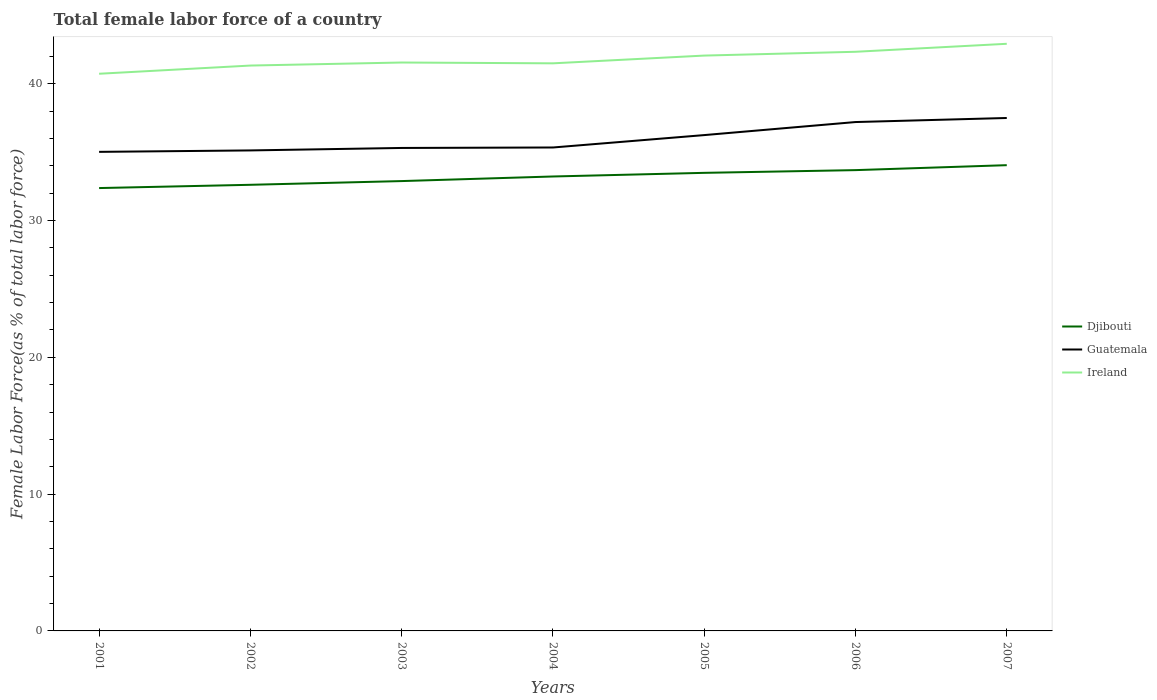How many different coloured lines are there?
Give a very brief answer. 3. Is the number of lines equal to the number of legend labels?
Offer a very short reply. Yes. Across all years, what is the maximum percentage of female labor force in Guatemala?
Provide a short and direct response. 35.02. In which year was the percentage of female labor force in Ireland maximum?
Your answer should be compact. 2001. What is the total percentage of female labor force in Djibouti in the graph?
Offer a terse response. -1.11. What is the difference between the highest and the second highest percentage of female labor force in Ireland?
Make the answer very short. 2.19. Is the percentage of female labor force in Djibouti strictly greater than the percentage of female labor force in Guatemala over the years?
Offer a terse response. Yes. How many lines are there?
Ensure brevity in your answer.  3. Are the values on the major ticks of Y-axis written in scientific E-notation?
Make the answer very short. No. Does the graph contain grids?
Offer a terse response. No. How many legend labels are there?
Your response must be concise. 3. How are the legend labels stacked?
Make the answer very short. Vertical. What is the title of the graph?
Your answer should be very brief. Total female labor force of a country. What is the label or title of the X-axis?
Your answer should be compact. Years. What is the label or title of the Y-axis?
Your response must be concise. Female Labor Force(as % of total labor force). What is the Female Labor Force(as % of total labor force) of Djibouti in 2001?
Your answer should be compact. 32.37. What is the Female Labor Force(as % of total labor force) of Guatemala in 2001?
Offer a very short reply. 35.02. What is the Female Labor Force(as % of total labor force) of Ireland in 2001?
Ensure brevity in your answer.  40.73. What is the Female Labor Force(as % of total labor force) in Djibouti in 2002?
Your answer should be compact. 32.61. What is the Female Labor Force(as % of total labor force) of Guatemala in 2002?
Ensure brevity in your answer.  35.13. What is the Female Labor Force(as % of total labor force) in Ireland in 2002?
Your answer should be very brief. 41.33. What is the Female Labor Force(as % of total labor force) in Djibouti in 2003?
Provide a short and direct response. 32.89. What is the Female Labor Force(as % of total labor force) in Guatemala in 2003?
Keep it short and to the point. 35.31. What is the Female Labor Force(as % of total labor force) in Ireland in 2003?
Ensure brevity in your answer.  41.55. What is the Female Labor Force(as % of total labor force) of Djibouti in 2004?
Make the answer very short. 33.22. What is the Female Labor Force(as % of total labor force) of Guatemala in 2004?
Ensure brevity in your answer.  35.34. What is the Female Labor Force(as % of total labor force) in Ireland in 2004?
Provide a short and direct response. 41.49. What is the Female Labor Force(as % of total labor force) of Djibouti in 2005?
Provide a short and direct response. 33.49. What is the Female Labor Force(as % of total labor force) of Guatemala in 2005?
Offer a very short reply. 36.25. What is the Female Labor Force(as % of total labor force) in Ireland in 2005?
Ensure brevity in your answer.  42.06. What is the Female Labor Force(as % of total labor force) of Djibouti in 2006?
Provide a succinct answer. 33.69. What is the Female Labor Force(as % of total labor force) of Guatemala in 2006?
Your answer should be compact. 37.2. What is the Female Labor Force(as % of total labor force) of Ireland in 2006?
Make the answer very short. 42.34. What is the Female Labor Force(as % of total labor force) in Djibouti in 2007?
Give a very brief answer. 34.05. What is the Female Labor Force(as % of total labor force) of Guatemala in 2007?
Keep it short and to the point. 37.5. What is the Female Labor Force(as % of total labor force) of Ireland in 2007?
Keep it short and to the point. 42.92. Across all years, what is the maximum Female Labor Force(as % of total labor force) of Djibouti?
Give a very brief answer. 34.05. Across all years, what is the maximum Female Labor Force(as % of total labor force) of Guatemala?
Your answer should be very brief. 37.5. Across all years, what is the maximum Female Labor Force(as % of total labor force) in Ireland?
Your response must be concise. 42.92. Across all years, what is the minimum Female Labor Force(as % of total labor force) of Djibouti?
Ensure brevity in your answer.  32.37. Across all years, what is the minimum Female Labor Force(as % of total labor force) of Guatemala?
Your answer should be very brief. 35.02. Across all years, what is the minimum Female Labor Force(as % of total labor force) of Ireland?
Provide a short and direct response. 40.73. What is the total Female Labor Force(as % of total labor force) of Djibouti in the graph?
Your answer should be very brief. 232.32. What is the total Female Labor Force(as % of total labor force) of Guatemala in the graph?
Provide a succinct answer. 251.74. What is the total Female Labor Force(as % of total labor force) in Ireland in the graph?
Offer a very short reply. 292.43. What is the difference between the Female Labor Force(as % of total labor force) in Djibouti in 2001 and that in 2002?
Give a very brief answer. -0.24. What is the difference between the Female Labor Force(as % of total labor force) in Guatemala in 2001 and that in 2002?
Provide a succinct answer. -0.1. What is the difference between the Female Labor Force(as % of total labor force) in Ireland in 2001 and that in 2002?
Provide a succinct answer. -0.6. What is the difference between the Female Labor Force(as % of total labor force) of Djibouti in 2001 and that in 2003?
Ensure brevity in your answer.  -0.51. What is the difference between the Female Labor Force(as % of total labor force) of Guatemala in 2001 and that in 2003?
Give a very brief answer. -0.29. What is the difference between the Female Labor Force(as % of total labor force) of Ireland in 2001 and that in 2003?
Keep it short and to the point. -0.82. What is the difference between the Female Labor Force(as % of total labor force) in Djibouti in 2001 and that in 2004?
Your answer should be very brief. -0.85. What is the difference between the Female Labor Force(as % of total labor force) in Guatemala in 2001 and that in 2004?
Make the answer very short. -0.32. What is the difference between the Female Labor Force(as % of total labor force) in Ireland in 2001 and that in 2004?
Ensure brevity in your answer.  -0.76. What is the difference between the Female Labor Force(as % of total labor force) in Djibouti in 2001 and that in 2005?
Your answer should be compact. -1.11. What is the difference between the Female Labor Force(as % of total labor force) in Guatemala in 2001 and that in 2005?
Give a very brief answer. -1.23. What is the difference between the Female Labor Force(as % of total labor force) of Ireland in 2001 and that in 2005?
Make the answer very short. -1.33. What is the difference between the Female Labor Force(as % of total labor force) in Djibouti in 2001 and that in 2006?
Your response must be concise. -1.31. What is the difference between the Female Labor Force(as % of total labor force) in Guatemala in 2001 and that in 2006?
Offer a terse response. -2.18. What is the difference between the Female Labor Force(as % of total labor force) of Ireland in 2001 and that in 2006?
Provide a short and direct response. -1.61. What is the difference between the Female Labor Force(as % of total labor force) of Djibouti in 2001 and that in 2007?
Keep it short and to the point. -1.67. What is the difference between the Female Labor Force(as % of total labor force) in Guatemala in 2001 and that in 2007?
Give a very brief answer. -2.48. What is the difference between the Female Labor Force(as % of total labor force) in Ireland in 2001 and that in 2007?
Your answer should be compact. -2.19. What is the difference between the Female Labor Force(as % of total labor force) of Djibouti in 2002 and that in 2003?
Offer a very short reply. -0.27. What is the difference between the Female Labor Force(as % of total labor force) in Guatemala in 2002 and that in 2003?
Keep it short and to the point. -0.18. What is the difference between the Female Labor Force(as % of total labor force) in Ireland in 2002 and that in 2003?
Your answer should be very brief. -0.22. What is the difference between the Female Labor Force(as % of total labor force) in Djibouti in 2002 and that in 2004?
Provide a short and direct response. -0.61. What is the difference between the Female Labor Force(as % of total labor force) of Guatemala in 2002 and that in 2004?
Ensure brevity in your answer.  -0.21. What is the difference between the Female Labor Force(as % of total labor force) in Ireland in 2002 and that in 2004?
Ensure brevity in your answer.  -0.16. What is the difference between the Female Labor Force(as % of total labor force) in Djibouti in 2002 and that in 2005?
Make the answer very short. -0.87. What is the difference between the Female Labor Force(as % of total labor force) of Guatemala in 2002 and that in 2005?
Offer a very short reply. -1.12. What is the difference between the Female Labor Force(as % of total labor force) of Ireland in 2002 and that in 2005?
Provide a short and direct response. -0.73. What is the difference between the Female Labor Force(as % of total labor force) in Djibouti in 2002 and that in 2006?
Offer a terse response. -1.07. What is the difference between the Female Labor Force(as % of total labor force) of Guatemala in 2002 and that in 2006?
Your response must be concise. -2.07. What is the difference between the Female Labor Force(as % of total labor force) in Ireland in 2002 and that in 2006?
Your answer should be very brief. -1.01. What is the difference between the Female Labor Force(as % of total labor force) in Djibouti in 2002 and that in 2007?
Keep it short and to the point. -1.43. What is the difference between the Female Labor Force(as % of total labor force) in Guatemala in 2002 and that in 2007?
Your answer should be very brief. -2.37. What is the difference between the Female Labor Force(as % of total labor force) of Ireland in 2002 and that in 2007?
Offer a very short reply. -1.59. What is the difference between the Female Labor Force(as % of total labor force) in Djibouti in 2003 and that in 2004?
Provide a succinct answer. -0.34. What is the difference between the Female Labor Force(as % of total labor force) in Guatemala in 2003 and that in 2004?
Offer a very short reply. -0.03. What is the difference between the Female Labor Force(as % of total labor force) of Djibouti in 2003 and that in 2005?
Offer a terse response. -0.6. What is the difference between the Female Labor Force(as % of total labor force) of Guatemala in 2003 and that in 2005?
Your response must be concise. -0.94. What is the difference between the Female Labor Force(as % of total labor force) of Ireland in 2003 and that in 2005?
Make the answer very short. -0.51. What is the difference between the Female Labor Force(as % of total labor force) of Djibouti in 2003 and that in 2006?
Your response must be concise. -0.8. What is the difference between the Female Labor Force(as % of total labor force) in Guatemala in 2003 and that in 2006?
Give a very brief answer. -1.89. What is the difference between the Female Labor Force(as % of total labor force) in Ireland in 2003 and that in 2006?
Keep it short and to the point. -0.78. What is the difference between the Female Labor Force(as % of total labor force) of Djibouti in 2003 and that in 2007?
Keep it short and to the point. -1.16. What is the difference between the Female Labor Force(as % of total labor force) of Guatemala in 2003 and that in 2007?
Offer a very short reply. -2.19. What is the difference between the Female Labor Force(as % of total labor force) of Ireland in 2003 and that in 2007?
Give a very brief answer. -1.37. What is the difference between the Female Labor Force(as % of total labor force) of Djibouti in 2004 and that in 2005?
Provide a short and direct response. -0.27. What is the difference between the Female Labor Force(as % of total labor force) in Guatemala in 2004 and that in 2005?
Your answer should be very brief. -0.91. What is the difference between the Female Labor Force(as % of total labor force) in Ireland in 2004 and that in 2005?
Give a very brief answer. -0.57. What is the difference between the Female Labor Force(as % of total labor force) of Djibouti in 2004 and that in 2006?
Make the answer very short. -0.46. What is the difference between the Female Labor Force(as % of total labor force) of Guatemala in 2004 and that in 2006?
Keep it short and to the point. -1.86. What is the difference between the Female Labor Force(as % of total labor force) in Ireland in 2004 and that in 2006?
Make the answer very short. -0.84. What is the difference between the Female Labor Force(as % of total labor force) in Djibouti in 2004 and that in 2007?
Make the answer very short. -0.83. What is the difference between the Female Labor Force(as % of total labor force) in Guatemala in 2004 and that in 2007?
Your answer should be very brief. -2.16. What is the difference between the Female Labor Force(as % of total labor force) of Ireland in 2004 and that in 2007?
Make the answer very short. -1.43. What is the difference between the Female Labor Force(as % of total labor force) in Djibouti in 2005 and that in 2006?
Keep it short and to the point. -0.2. What is the difference between the Female Labor Force(as % of total labor force) of Guatemala in 2005 and that in 2006?
Offer a very short reply. -0.95. What is the difference between the Female Labor Force(as % of total labor force) of Ireland in 2005 and that in 2006?
Your response must be concise. -0.28. What is the difference between the Female Labor Force(as % of total labor force) in Djibouti in 2005 and that in 2007?
Provide a succinct answer. -0.56. What is the difference between the Female Labor Force(as % of total labor force) in Guatemala in 2005 and that in 2007?
Ensure brevity in your answer.  -1.25. What is the difference between the Female Labor Force(as % of total labor force) of Ireland in 2005 and that in 2007?
Your answer should be very brief. -0.86. What is the difference between the Female Labor Force(as % of total labor force) in Djibouti in 2006 and that in 2007?
Provide a succinct answer. -0.36. What is the difference between the Female Labor Force(as % of total labor force) of Guatemala in 2006 and that in 2007?
Keep it short and to the point. -0.3. What is the difference between the Female Labor Force(as % of total labor force) of Ireland in 2006 and that in 2007?
Offer a very short reply. -0.58. What is the difference between the Female Labor Force(as % of total labor force) in Djibouti in 2001 and the Female Labor Force(as % of total labor force) in Guatemala in 2002?
Your answer should be very brief. -2.75. What is the difference between the Female Labor Force(as % of total labor force) in Djibouti in 2001 and the Female Labor Force(as % of total labor force) in Ireland in 2002?
Offer a very short reply. -8.96. What is the difference between the Female Labor Force(as % of total labor force) of Guatemala in 2001 and the Female Labor Force(as % of total labor force) of Ireland in 2002?
Your answer should be compact. -6.31. What is the difference between the Female Labor Force(as % of total labor force) in Djibouti in 2001 and the Female Labor Force(as % of total labor force) in Guatemala in 2003?
Offer a very short reply. -2.93. What is the difference between the Female Labor Force(as % of total labor force) in Djibouti in 2001 and the Female Labor Force(as % of total labor force) in Ireland in 2003?
Offer a terse response. -9.18. What is the difference between the Female Labor Force(as % of total labor force) of Guatemala in 2001 and the Female Labor Force(as % of total labor force) of Ireland in 2003?
Make the answer very short. -6.53. What is the difference between the Female Labor Force(as % of total labor force) of Djibouti in 2001 and the Female Labor Force(as % of total labor force) of Guatemala in 2004?
Give a very brief answer. -2.97. What is the difference between the Female Labor Force(as % of total labor force) of Djibouti in 2001 and the Female Labor Force(as % of total labor force) of Ireland in 2004?
Offer a very short reply. -9.12. What is the difference between the Female Labor Force(as % of total labor force) in Guatemala in 2001 and the Female Labor Force(as % of total labor force) in Ireland in 2004?
Your answer should be compact. -6.47. What is the difference between the Female Labor Force(as % of total labor force) of Djibouti in 2001 and the Female Labor Force(as % of total labor force) of Guatemala in 2005?
Your answer should be compact. -3.87. What is the difference between the Female Labor Force(as % of total labor force) of Djibouti in 2001 and the Female Labor Force(as % of total labor force) of Ireland in 2005?
Ensure brevity in your answer.  -9.69. What is the difference between the Female Labor Force(as % of total labor force) in Guatemala in 2001 and the Female Labor Force(as % of total labor force) in Ireland in 2005?
Keep it short and to the point. -7.04. What is the difference between the Female Labor Force(as % of total labor force) in Djibouti in 2001 and the Female Labor Force(as % of total labor force) in Guatemala in 2006?
Your answer should be very brief. -4.83. What is the difference between the Female Labor Force(as % of total labor force) in Djibouti in 2001 and the Female Labor Force(as % of total labor force) in Ireland in 2006?
Provide a short and direct response. -9.96. What is the difference between the Female Labor Force(as % of total labor force) in Guatemala in 2001 and the Female Labor Force(as % of total labor force) in Ireland in 2006?
Make the answer very short. -7.32. What is the difference between the Female Labor Force(as % of total labor force) in Djibouti in 2001 and the Female Labor Force(as % of total labor force) in Guatemala in 2007?
Make the answer very short. -5.12. What is the difference between the Female Labor Force(as % of total labor force) in Djibouti in 2001 and the Female Labor Force(as % of total labor force) in Ireland in 2007?
Make the answer very short. -10.55. What is the difference between the Female Labor Force(as % of total labor force) in Guatemala in 2001 and the Female Labor Force(as % of total labor force) in Ireland in 2007?
Offer a terse response. -7.9. What is the difference between the Female Labor Force(as % of total labor force) of Djibouti in 2002 and the Female Labor Force(as % of total labor force) of Guatemala in 2003?
Provide a short and direct response. -2.69. What is the difference between the Female Labor Force(as % of total labor force) of Djibouti in 2002 and the Female Labor Force(as % of total labor force) of Ireland in 2003?
Your answer should be very brief. -8.94. What is the difference between the Female Labor Force(as % of total labor force) of Guatemala in 2002 and the Female Labor Force(as % of total labor force) of Ireland in 2003?
Offer a very short reply. -6.43. What is the difference between the Female Labor Force(as % of total labor force) in Djibouti in 2002 and the Female Labor Force(as % of total labor force) in Guatemala in 2004?
Give a very brief answer. -2.73. What is the difference between the Female Labor Force(as % of total labor force) in Djibouti in 2002 and the Female Labor Force(as % of total labor force) in Ireland in 2004?
Provide a succinct answer. -8.88. What is the difference between the Female Labor Force(as % of total labor force) of Guatemala in 2002 and the Female Labor Force(as % of total labor force) of Ireland in 2004?
Provide a short and direct response. -6.37. What is the difference between the Female Labor Force(as % of total labor force) in Djibouti in 2002 and the Female Labor Force(as % of total labor force) in Guatemala in 2005?
Your answer should be very brief. -3.63. What is the difference between the Female Labor Force(as % of total labor force) of Djibouti in 2002 and the Female Labor Force(as % of total labor force) of Ireland in 2005?
Offer a very short reply. -9.45. What is the difference between the Female Labor Force(as % of total labor force) in Guatemala in 2002 and the Female Labor Force(as % of total labor force) in Ireland in 2005?
Provide a short and direct response. -6.93. What is the difference between the Female Labor Force(as % of total labor force) in Djibouti in 2002 and the Female Labor Force(as % of total labor force) in Guatemala in 2006?
Give a very brief answer. -4.59. What is the difference between the Female Labor Force(as % of total labor force) in Djibouti in 2002 and the Female Labor Force(as % of total labor force) in Ireland in 2006?
Provide a succinct answer. -9.72. What is the difference between the Female Labor Force(as % of total labor force) of Guatemala in 2002 and the Female Labor Force(as % of total labor force) of Ireland in 2006?
Your response must be concise. -7.21. What is the difference between the Female Labor Force(as % of total labor force) of Djibouti in 2002 and the Female Labor Force(as % of total labor force) of Guatemala in 2007?
Make the answer very short. -4.88. What is the difference between the Female Labor Force(as % of total labor force) of Djibouti in 2002 and the Female Labor Force(as % of total labor force) of Ireland in 2007?
Offer a terse response. -10.31. What is the difference between the Female Labor Force(as % of total labor force) of Guatemala in 2002 and the Female Labor Force(as % of total labor force) of Ireland in 2007?
Offer a very short reply. -7.8. What is the difference between the Female Labor Force(as % of total labor force) of Djibouti in 2003 and the Female Labor Force(as % of total labor force) of Guatemala in 2004?
Provide a succinct answer. -2.46. What is the difference between the Female Labor Force(as % of total labor force) of Djibouti in 2003 and the Female Labor Force(as % of total labor force) of Ireland in 2004?
Make the answer very short. -8.61. What is the difference between the Female Labor Force(as % of total labor force) in Guatemala in 2003 and the Female Labor Force(as % of total labor force) in Ireland in 2004?
Your answer should be very brief. -6.19. What is the difference between the Female Labor Force(as % of total labor force) in Djibouti in 2003 and the Female Labor Force(as % of total labor force) in Guatemala in 2005?
Your response must be concise. -3.36. What is the difference between the Female Labor Force(as % of total labor force) of Djibouti in 2003 and the Female Labor Force(as % of total labor force) of Ireland in 2005?
Provide a succinct answer. -9.17. What is the difference between the Female Labor Force(as % of total labor force) of Guatemala in 2003 and the Female Labor Force(as % of total labor force) of Ireland in 2005?
Offer a very short reply. -6.75. What is the difference between the Female Labor Force(as % of total labor force) of Djibouti in 2003 and the Female Labor Force(as % of total labor force) of Guatemala in 2006?
Offer a very short reply. -4.32. What is the difference between the Female Labor Force(as % of total labor force) of Djibouti in 2003 and the Female Labor Force(as % of total labor force) of Ireland in 2006?
Make the answer very short. -9.45. What is the difference between the Female Labor Force(as % of total labor force) of Guatemala in 2003 and the Female Labor Force(as % of total labor force) of Ireland in 2006?
Provide a short and direct response. -7.03. What is the difference between the Female Labor Force(as % of total labor force) of Djibouti in 2003 and the Female Labor Force(as % of total labor force) of Guatemala in 2007?
Provide a succinct answer. -4.61. What is the difference between the Female Labor Force(as % of total labor force) of Djibouti in 2003 and the Female Labor Force(as % of total labor force) of Ireland in 2007?
Keep it short and to the point. -10.04. What is the difference between the Female Labor Force(as % of total labor force) of Guatemala in 2003 and the Female Labor Force(as % of total labor force) of Ireland in 2007?
Offer a very short reply. -7.61. What is the difference between the Female Labor Force(as % of total labor force) of Djibouti in 2004 and the Female Labor Force(as % of total labor force) of Guatemala in 2005?
Make the answer very short. -3.03. What is the difference between the Female Labor Force(as % of total labor force) in Djibouti in 2004 and the Female Labor Force(as % of total labor force) in Ireland in 2005?
Offer a terse response. -8.84. What is the difference between the Female Labor Force(as % of total labor force) of Guatemala in 2004 and the Female Labor Force(as % of total labor force) of Ireland in 2005?
Ensure brevity in your answer.  -6.72. What is the difference between the Female Labor Force(as % of total labor force) of Djibouti in 2004 and the Female Labor Force(as % of total labor force) of Guatemala in 2006?
Keep it short and to the point. -3.98. What is the difference between the Female Labor Force(as % of total labor force) in Djibouti in 2004 and the Female Labor Force(as % of total labor force) in Ireland in 2006?
Keep it short and to the point. -9.12. What is the difference between the Female Labor Force(as % of total labor force) in Guatemala in 2004 and the Female Labor Force(as % of total labor force) in Ireland in 2006?
Offer a very short reply. -7. What is the difference between the Female Labor Force(as % of total labor force) of Djibouti in 2004 and the Female Labor Force(as % of total labor force) of Guatemala in 2007?
Make the answer very short. -4.28. What is the difference between the Female Labor Force(as % of total labor force) in Djibouti in 2004 and the Female Labor Force(as % of total labor force) in Ireland in 2007?
Make the answer very short. -9.7. What is the difference between the Female Labor Force(as % of total labor force) in Guatemala in 2004 and the Female Labor Force(as % of total labor force) in Ireland in 2007?
Your response must be concise. -7.58. What is the difference between the Female Labor Force(as % of total labor force) of Djibouti in 2005 and the Female Labor Force(as % of total labor force) of Guatemala in 2006?
Ensure brevity in your answer.  -3.71. What is the difference between the Female Labor Force(as % of total labor force) of Djibouti in 2005 and the Female Labor Force(as % of total labor force) of Ireland in 2006?
Your response must be concise. -8.85. What is the difference between the Female Labor Force(as % of total labor force) of Guatemala in 2005 and the Female Labor Force(as % of total labor force) of Ireland in 2006?
Make the answer very short. -6.09. What is the difference between the Female Labor Force(as % of total labor force) of Djibouti in 2005 and the Female Labor Force(as % of total labor force) of Guatemala in 2007?
Your response must be concise. -4.01. What is the difference between the Female Labor Force(as % of total labor force) in Djibouti in 2005 and the Female Labor Force(as % of total labor force) in Ireland in 2007?
Ensure brevity in your answer.  -9.43. What is the difference between the Female Labor Force(as % of total labor force) in Guatemala in 2005 and the Female Labor Force(as % of total labor force) in Ireland in 2007?
Offer a very short reply. -6.67. What is the difference between the Female Labor Force(as % of total labor force) in Djibouti in 2006 and the Female Labor Force(as % of total labor force) in Guatemala in 2007?
Provide a short and direct response. -3.81. What is the difference between the Female Labor Force(as % of total labor force) of Djibouti in 2006 and the Female Labor Force(as % of total labor force) of Ireland in 2007?
Provide a succinct answer. -9.24. What is the difference between the Female Labor Force(as % of total labor force) of Guatemala in 2006 and the Female Labor Force(as % of total labor force) of Ireland in 2007?
Your answer should be compact. -5.72. What is the average Female Labor Force(as % of total labor force) in Djibouti per year?
Your response must be concise. 33.19. What is the average Female Labor Force(as % of total labor force) of Guatemala per year?
Offer a terse response. 35.96. What is the average Female Labor Force(as % of total labor force) of Ireland per year?
Offer a very short reply. 41.78. In the year 2001, what is the difference between the Female Labor Force(as % of total labor force) of Djibouti and Female Labor Force(as % of total labor force) of Guatemala?
Make the answer very short. -2.65. In the year 2001, what is the difference between the Female Labor Force(as % of total labor force) in Djibouti and Female Labor Force(as % of total labor force) in Ireland?
Offer a very short reply. -8.36. In the year 2001, what is the difference between the Female Labor Force(as % of total labor force) of Guatemala and Female Labor Force(as % of total labor force) of Ireland?
Provide a succinct answer. -5.71. In the year 2002, what is the difference between the Female Labor Force(as % of total labor force) of Djibouti and Female Labor Force(as % of total labor force) of Guatemala?
Provide a short and direct response. -2.51. In the year 2002, what is the difference between the Female Labor Force(as % of total labor force) in Djibouti and Female Labor Force(as % of total labor force) in Ireland?
Your answer should be very brief. -8.72. In the year 2002, what is the difference between the Female Labor Force(as % of total labor force) in Guatemala and Female Labor Force(as % of total labor force) in Ireland?
Offer a terse response. -6.2. In the year 2003, what is the difference between the Female Labor Force(as % of total labor force) in Djibouti and Female Labor Force(as % of total labor force) in Guatemala?
Your response must be concise. -2.42. In the year 2003, what is the difference between the Female Labor Force(as % of total labor force) of Djibouti and Female Labor Force(as % of total labor force) of Ireland?
Ensure brevity in your answer.  -8.67. In the year 2003, what is the difference between the Female Labor Force(as % of total labor force) in Guatemala and Female Labor Force(as % of total labor force) in Ireland?
Your answer should be compact. -6.25. In the year 2004, what is the difference between the Female Labor Force(as % of total labor force) of Djibouti and Female Labor Force(as % of total labor force) of Guatemala?
Your answer should be very brief. -2.12. In the year 2004, what is the difference between the Female Labor Force(as % of total labor force) in Djibouti and Female Labor Force(as % of total labor force) in Ireland?
Your answer should be very brief. -8.27. In the year 2004, what is the difference between the Female Labor Force(as % of total labor force) in Guatemala and Female Labor Force(as % of total labor force) in Ireland?
Keep it short and to the point. -6.15. In the year 2005, what is the difference between the Female Labor Force(as % of total labor force) of Djibouti and Female Labor Force(as % of total labor force) of Guatemala?
Your response must be concise. -2.76. In the year 2005, what is the difference between the Female Labor Force(as % of total labor force) of Djibouti and Female Labor Force(as % of total labor force) of Ireland?
Your answer should be very brief. -8.57. In the year 2005, what is the difference between the Female Labor Force(as % of total labor force) of Guatemala and Female Labor Force(as % of total labor force) of Ireland?
Keep it short and to the point. -5.81. In the year 2006, what is the difference between the Female Labor Force(as % of total labor force) of Djibouti and Female Labor Force(as % of total labor force) of Guatemala?
Offer a terse response. -3.52. In the year 2006, what is the difference between the Female Labor Force(as % of total labor force) in Djibouti and Female Labor Force(as % of total labor force) in Ireland?
Offer a terse response. -8.65. In the year 2006, what is the difference between the Female Labor Force(as % of total labor force) of Guatemala and Female Labor Force(as % of total labor force) of Ireland?
Ensure brevity in your answer.  -5.14. In the year 2007, what is the difference between the Female Labor Force(as % of total labor force) of Djibouti and Female Labor Force(as % of total labor force) of Guatemala?
Your response must be concise. -3.45. In the year 2007, what is the difference between the Female Labor Force(as % of total labor force) in Djibouti and Female Labor Force(as % of total labor force) in Ireland?
Offer a terse response. -8.87. In the year 2007, what is the difference between the Female Labor Force(as % of total labor force) in Guatemala and Female Labor Force(as % of total labor force) in Ireland?
Make the answer very short. -5.42. What is the ratio of the Female Labor Force(as % of total labor force) in Djibouti in 2001 to that in 2002?
Your response must be concise. 0.99. What is the ratio of the Female Labor Force(as % of total labor force) of Guatemala in 2001 to that in 2002?
Provide a succinct answer. 1. What is the ratio of the Female Labor Force(as % of total labor force) in Ireland in 2001 to that in 2002?
Keep it short and to the point. 0.99. What is the ratio of the Female Labor Force(as % of total labor force) of Djibouti in 2001 to that in 2003?
Keep it short and to the point. 0.98. What is the ratio of the Female Labor Force(as % of total labor force) of Guatemala in 2001 to that in 2003?
Your answer should be very brief. 0.99. What is the ratio of the Female Labor Force(as % of total labor force) in Ireland in 2001 to that in 2003?
Your answer should be very brief. 0.98. What is the ratio of the Female Labor Force(as % of total labor force) of Djibouti in 2001 to that in 2004?
Provide a succinct answer. 0.97. What is the ratio of the Female Labor Force(as % of total labor force) of Ireland in 2001 to that in 2004?
Offer a terse response. 0.98. What is the ratio of the Female Labor Force(as % of total labor force) of Djibouti in 2001 to that in 2005?
Offer a very short reply. 0.97. What is the ratio of the Female Labor Force(as % of total labor force) in Guatemala in 2001 to that in 2005?
Make the answer very short. 0.97. What is the ratio of the Female Labor Force(as % of total labor force) in Ireland in 2001 to that in 2005?
Offer a very short reply. 0.97. What is the ratio of the Female Labor Force(as % of total labor force) in Djibouti in 2001 to that in 2006?
Give a very brief answer. 0.96. What is the ratio of the Female Labor Force(as % of total labor force) in Guatemala in 2001 to that in 2006?
Keep it short and to the point. 0.94. What is the ratio of the Female Labor Force(as % of total labor force) in Ireland in 2001 to that in 2006?
Your response must be concise. 0.96. What is the ratio of the Female Labor Force(as % of total labor force) in Djibouti in 2001 to that in 2007?
Ensure brevity in your answer.  0.95. What is the ratio of the Female Labor Force(as % of total labor force) in Guatemala in 2001 to that in 2007?
Provide a short and direct response. 0.93. What is the ratio of the Female Labor Force(as % of total labor force) of Ireland in 2001 to that in 2007?
Provide a short and direct response. 0.95. What is the ratio of the Female Labor Force(as % of total labor force) in Djibouti in 2002 to that in 2003?
Keep it short and to the point. 0.99. What is the ratio of the Female Labor Force(as % of total labor force) in Djibouti in 2002 to that in 2004?
Keep it short and to the point. 0.98. What is the ratio of the Female Labor Force(as % of total labor force) in Djibouti in 2002 to that in 2005?
Make the answer very short. 0.97. What is the ratio of the Female Labor Force(as % of total labor force) in Guatemala in 2002 to that in 2005?
Offer a terse response. 0.97. What is the ratio of the Female Labor Force(as % of total labor force) in Ireland in 2002 to that in 2005?
Your answer should be compact. 0.98. What is the ratio of the Female Labor Force(as % of total labor force) of Djibouti in 2002 to that in 2006?
Your answer should be very brief. 0.97. What is the ratio of the Female Labor Force(as % of total labor force) of Guatemala in 2002 to that in 2006?
Give a very brief answer. 0.94. What is the ratio of the Female Labor Force(as % of total labor force) of Ireland in 2002 to that in 2006?
Offer a very short reply. 0.98. What is the ratio of the Female Labor Force(as % of total labor force) in Djibouti in 2002 to that in 2007?
Offer a very short reply. 0.96. What is the ratio of the Female Labor Force(as % of total labor force) of Guatemala in 2002 to that in 2007?
Ensure brevity in your answer.  0.94. What is the ratio of the Female Labor Force(as % of total labor force) in Ireland in 2002 to that in 2007?
Provide a short and direct response. 0.96. What is the ratio of the Female Labor Force(as % of total labor force) in Djibouti in 2003 to that in 2004?
Offer a terse response. 0.99. What is the ratio of the Female Labor Force(as % of total labor force) in Guatemala in 2003 to that in 2005?
Provide a succinct answer. 0.97. What is the ratio of the Female Labor Force(as % of total labor force) of Ireland in 2003 to that in 2005?
Offer a terse response. 0.99. What is the ratio of the Female Labor Force(as % of total labor force) of Djibouti in 2003 to that in 2006?
Provide a short and direct response. 0.98. What is the ratio of the Female Labor Force(as % of total labor force) of Guatemala in 2003 to that in 2006?
Your response must be concise. 0.95. What is the ratio of the Female Labor Force(as % of total labor force) in Ireland in 2003 to that in 2006?
Ensure brevity in your answer.  0.98. What is the ratio of the Female Labor Force(as % of total labor force) in Djibouti in 2003 to that in 2007?
Offer a very short reply. 0.97. What is the ratio of the Female Labor Force(as % of total labor force) of Guatemala in 2003 to that in 2007?
Give a very brief answer. 0.94. What is the ratio of the Female Labor Force(as % of total labor force) of Ireland in 2003 to that in 2007?
Provide a succinct answer. 0.97. What is the ratio of the Female Labor Force(as % of total labor force) in Djibouti in 2004 to that in 2005?
Give a very brief answer. 0.99. What is the ratio of the Female Labor Force(as % of total labor force) of Ireland in 2004 to that in 2005?
Your answer should be compact. 0.99. What is the ratio of the Female Labor Force(as % of total labor force) of Djibouti in 2004 to that in 2006?
Your response must be concise. 0.99. What is the ratio of the Female Labor Force(as % of total labor force) in Guatemala in 2004 to that in 2006?
Your response must be concise. 0.95. What is the ratio of the Female Labor Force(as % of total labor force) in Djibouti in 2004 to that in 2007?
Keep it short and to the point. 0.98. What is the ratio of the Female Labor Force(as % of total labor force) of Guatemala in 2004 to that in 2007?
Provide a succinct answer. 0.94. What is the ratio of the Female Labor Force(as % of total labor force) of Ireland in 2004 to that in 2007?
Offer a terse response. 0.97. What is the ratio of the Female Labor Force(as % of total labor force) of Djibouti in 2005 to that in 2006?
Your answer should be compact. 0.99. What is the ratio of the Female Labor Force(as % of total labor force) of Guatemala in 2005 to that in 2006?
Offer a very short reply. 0.97. What is the ratio of the Female Labor Force(as % of total labor force) of Ireland in 2005 to that in 2006?
Offer a terse response. 0.99. What is the ratio of the Female Labor Force(as % of total labor force) of Djibouti in 2005 to that in 2007?
Make the answer very short. 0.98. What is the ratio of the Female Labor Force(as % of total labor force) in Guatemala in 2005 to that in 2007?
Ensure brevity in your answer.  0.97. What is the ratio of the Female Labor Force(as % of total labor force) of Ireland in 2005 to that in 2007?
Give a very brief answer. 0.98. What is the ratio of the Female Labor Force(as % of total labor force) in Ireland in 2006 to that in 2007?
Your response must be concise. 0.99. What is the difference between the highest and the second highest Female Labor Force(as % of total labor force) in Djibouti?
Make the answer very short. 0.36. What is the difference between the highest and the second highest Female Labor Force(as % of total labor force) of Guatemala?
Provide a short and direct response. 0.3. What is the difference between the highest and the second highest Female Labor Force(as % of total labor force) in Ireland?
Offer a terse response. 0.58. What is the difference between the highest and the lowest Female Labor Force(as % of total labor force) of Djibouti?
Your response must be concise. 1.67. What is the difference between the highest and the lowest Female Labor Force(as % of total labor force) in Guatemala?
Your response must be concise. 2.48. What is the difference between the highest and the lowest Female Labor Force(as % of total labor force) in Ireland?
Make the answer very short. 2.19. 